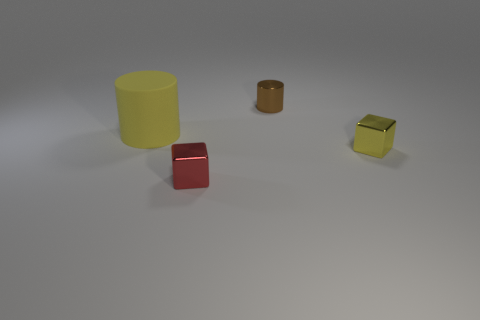Add 3 tiny metallic cylinders. How many objects exist? 7 Subtract 2 blocks. How many blocks are left? 0 Subtract all blue spheres. How many yellow cubes are left? 1 Subtract all brown cylinders. How many cylinders are left? 1 Subtract all blue cylinders. Subtract all yellow balls. How many cylinders are left? 2 Subtract all yellow cylinders. Subtract all tiny yellow things. How many objects are left? 2 Add 4 small metal cubes. How many small metal cubes are left? 6 Add 2 brown cylinders. How many brown cylinders exist? 3 Subtract 0 blue cubes. How many objects are left? 4 